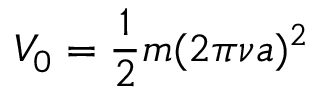<formula> <loc_0><loc_0><loc_500><loc_500>V _ { 0 } = \frac { 1 } { 2 } m ( 2 \pi \nu a ) ^ { 2 }</formula> 